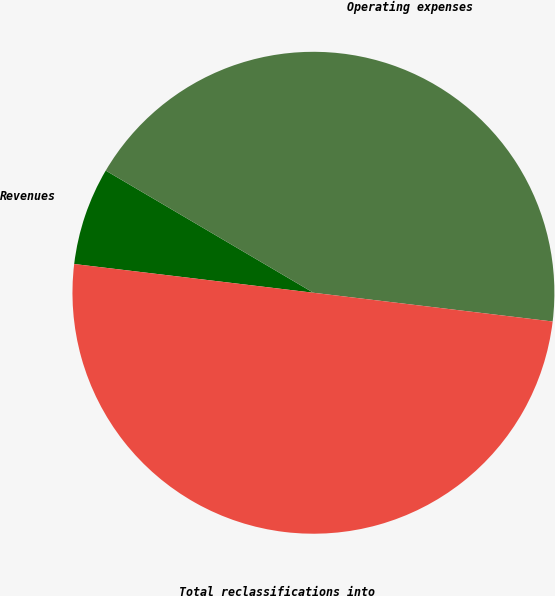Convert chart. <chart><loc_0><loc_0><loc_500><loc_500><pie_chart><fcel>Revenues<fcel>Operating expenses<fcel>Total reclassifications into<nl><fcel>6.56%<fcel>43.44%<fcel>50.0%<nl></chart> 